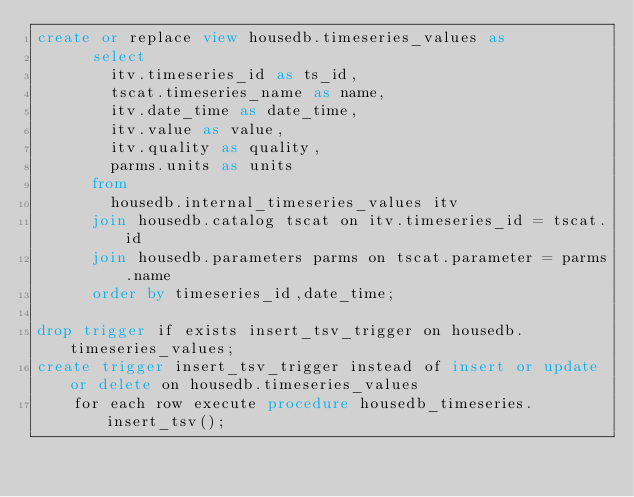Convert code to text. <code><loc_0><loc_0><loc_500><loc_500><_SQL_>create or replace view housedb.timeseries_values as 
      select 
        itv.timeseries_id as ts_id,        
        tscat.timeseries_name as name,
        itv.date_time as date_time,
        itv.value as value,
        itv.quality as quality,
        parms.units as units
      from 
        housedb.internal_timeseries_values itv
      join housedb.catalog tscat on itv.timeseries_id = tscat.id
      join housedb.parameters parms on tscat.parameter = parms.name
      order by timeseries_id,date_time;

drop trigger if exists insert_tsv_trigger on housedb.timeseries_values;
create trigger insert_tsv_trigger instead of insert or update or delete on housedb.timeseries_values 
    for each row execute procedure housedb_timeseries.insert_tsv();      </code> 